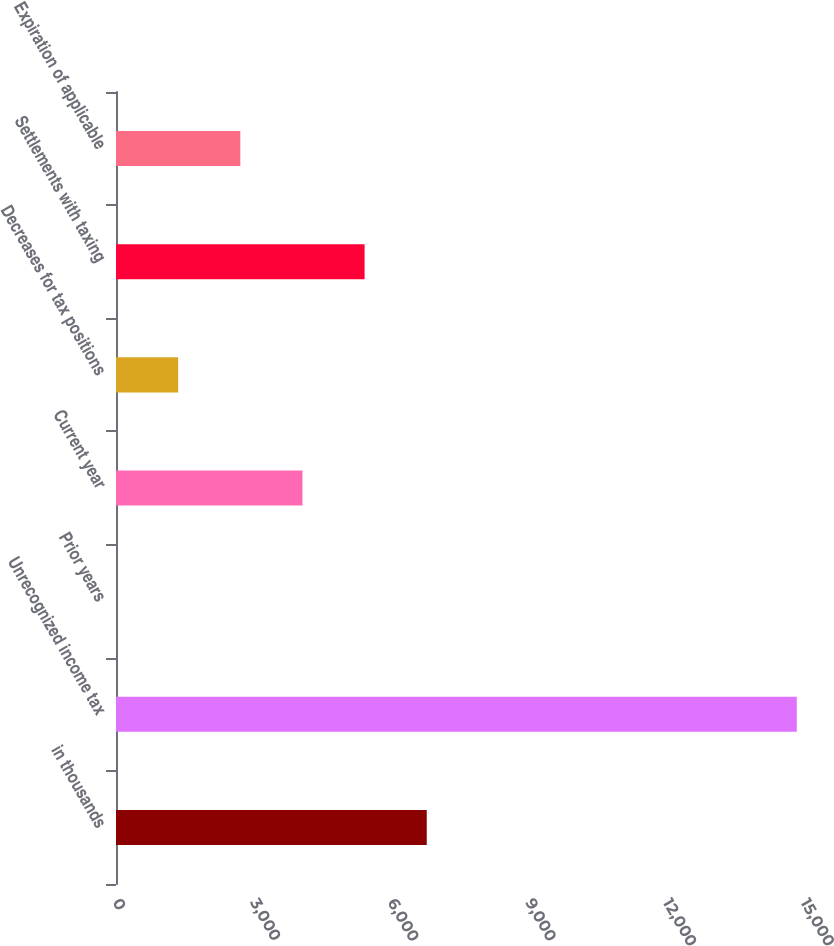<chart> <loc_0><loc_0><loc_500><loc_500><bar_chart><fcel>in thousands<fcel>Unrecognized income tax<fcel>Prior years<fcel>Current year<fcel>Decreases for tax positions<fcel>Settlements with taxing<fcel>Expiration of applicable<nl><fcel>6775.09<fcel>14843<fcel>0.15<fcel>4065.11<fcel>1355.14<fcel>5420.1<fcel>2710.12<nl></chart> 